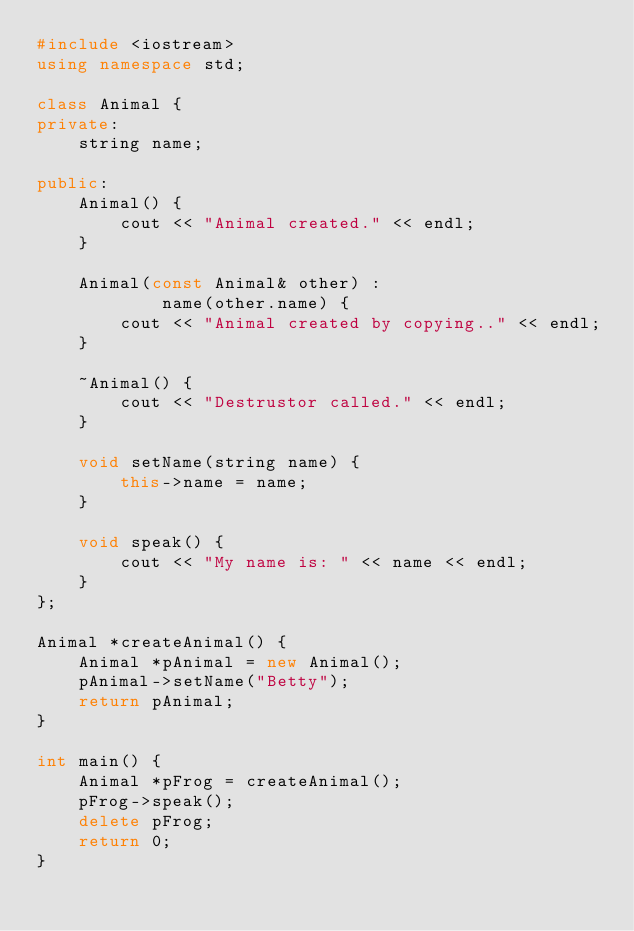Convert code to text. <code><loc_0><loc_0><loc_500><loc_500><_C++_>#include <iostream>
using namespace std;

class Animal {
private:
	string name;

public:
	Animal() {
		cout << "Animal created." << endl;
	}

	Animal(const Animal& other) :
			name(other.name) {
		cout << "Animal created by copying.." << endl;
	}

	~Animal() {
		cout << "Destrustor called." << endl;
	}

	void setName(string name) {
		this->name = name;
	}

	void speak() {
		cout << "My name is: " << name << endl;
	}
};

Animal *createAnimal() {
	Animal *pAnimal = new Animal();
	pAnimal->setName("Betty");
	return pAnimal;
}

int main() {
	Animal *pFrog = createAnimal();
	pFrog->speak();
	delete pFrog;
	return 0;
}
</code> 